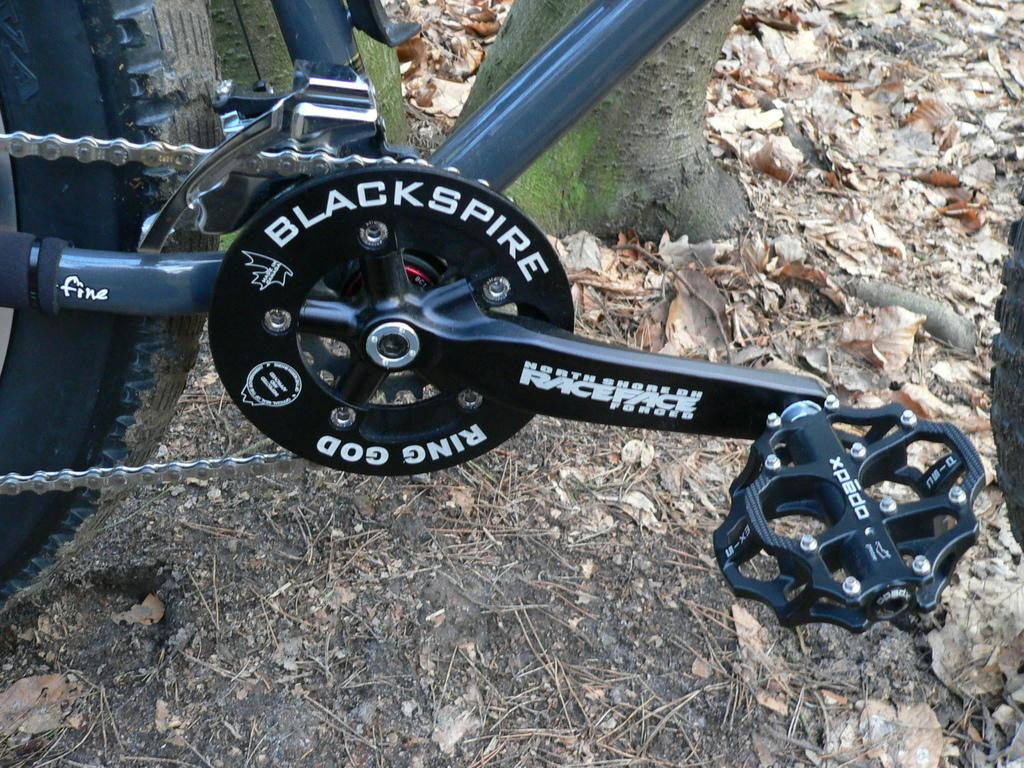What is the main object in the image? There is a bicycle in the image. What can be seen on the ground in the image? There are dried leaves on the ground in the image. What type of plot is being discussed in the image? There is no plot being discussed in the image, as the image only features a bicycle and dried leaves on the ground. What property is being shown in the image? The image does not depict a specific property; it simply shows a bicycle and dried leaves on the ground. 